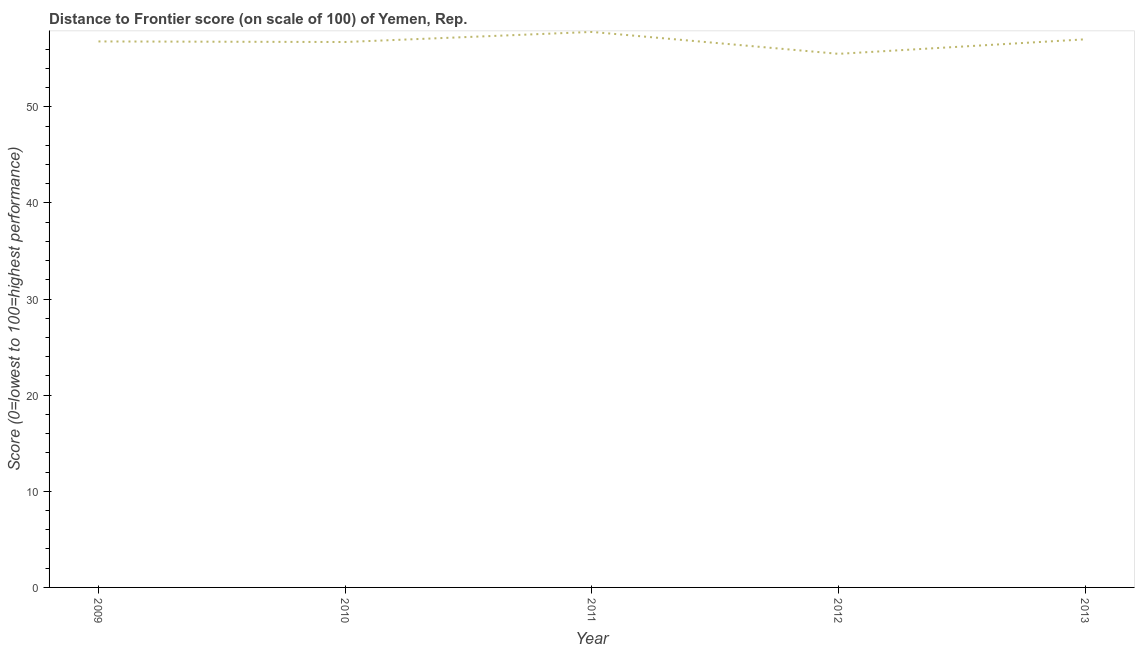What is the distance to frontier score in 2010?
Your response must be concise. 56.74. Across all years, what is the maximum distance to frontier score?
Keep it short and to the point. 57.79. Across all years, what is the minimum distance to frontier score?
Your answer should be compact. 55.51. In which year was the distance to frontier score minimum?
Offer a very short reply. 2012. What is the sum of the distance to frontier score?
Provide a succinct answer. 283.86. What is the difference between the distance to frontier score in 2010 and 2011?
Your answer should be compact. -1.05. What is the average distance to frontier score per year?
Your answer should be compact. 56.77. What is the median distance to frontier score?
Ensure brevity in your answer.  56.8. In how many years, is the distance to frontier score greater than 50 ?
Provide a short and direct response. 5. Do a majority of the years between 2009 and 2011 (inclusive) have distance to frontier score greater than 52 ?
Keep it short and to the point. Yes. What is the ratio of the distance to frontier score in 2010 to that in 2012?
Your response must be concise. 1.02. Is the distance to frontier score in 2009 less than that in 2013?
Give a very brief answer. Yes. Is the difference between the distance to frontier score in 2009 and 2010 greater than the difference between any two years?
Give a very brief answer. No. What is the difference between the highest and the second highest distance to frontier score?
Offer a terse response. 0.77. What is the difference between the highest and the lowest distance to frontier score?
Keep it short and to the point. 2.28. In how many years, is the distance to frontier score greater than the average distance to frontier score taken over all years?
Offer a very short reply. 3. Does the distance to frontier score monotonically increase over the years?
Offer a very short reply. No. How many lines are there?
Offer a very short reply. 1. What is the difference between two consecutive major ticks on the Y-axis?
Your answer should be compact. 10. Does the graph contain any zero values?
Your answer should be very brief. No. What is the title of the graph?
Provide a succinct answer. Distance to Frontier score (on scale of 100) of Yemen, Rep. What is the label or title of the Y-axis?
Your answer should be very brief. Score (0=lowest to 100=highest performance). What is the Score (0=lowest to 100=highest performance) in 2009?
Keep it short and to the point. 56.8. What is the Score (0=lowest to 100=highest performance) of 2010?
Offer a very short reply. 56.74. What is the Score (0=lowest to 100=highest performance) of 2011?
Provide a short and direct response. 57.79. What is the Score (0=lowest to 100=highest performance) of 2012?
Provide a succinct answer. 55.51. What is the Score (0=lowest to 100=highest performance) in 2013?
Make the answer very short. 57.02. What is the difference between the Score (0=lowest to 100=highest performance) in 2009 and 2010?
Provide a succinct answer. 0.06. What is the difference between the Score (0=lowest to 100=highest performance) in 2009 and 2011?
Make the answer very short. -0.99. What is the difference between the Score (0=lowest to 100=highest performance) in 2009 and 2012?
Provide a short and direct response. 1.29. What is the difference between the Score (0=lowest to 100=highest performance) in 2009 and 2013?
Make the answer very short. -0.22. What is the difference between the Score (0=lowest to 100=highest performance) in 2010 and 2011?
Make the answer very short. -1.05. What is the difference between the Score (0=lowest to 100=highest performance) in 2010 and 2012?
Ensure brevity in your answer.  1.23. What is the difference between the Score (0=lowest to 100=highest performance) in 2010 and 2013?
Ensure brevity in your answer.  -0.28. What is the difference between the Score (0=lowest to 100=highest performance) in 2011 and 2012?
Your answer should be compact. 2.28. What is the difference between the Score (0=lowest to 100=highest performance) in 2011 and 2013?
Make the answer very short. 0.77. What is the difference between the Score (0=lowest to 100=highest performance) in 2012 and 2013?
Provide a short and direct response. -1.51. What is the ratio of the Score (0=lowest to 100=highest performance) in 2009 to that in 2010?
Offer a terse response. 1. What is the ratio of the Score (0=lowest to 100=highest performance) in 2009 to that in 2012?
Your answer should be very brief. 1.02. What is the ratio of the Score (0=lowest to 100=highest performance) in 2010 to that in 2012?
Offer a terse response. 1.02. What is the ratio of the Score (0=lowest to 100=highest performance) in 2010 to that in 2013?
Offer a very short reply. 0.99. What is the ratio of the Score (0=lowest to 100=highest performance) in 2011 to that in 2012?
Your answer should be very brief. 1.04. What is the ratio of the Score (0=lowest to 100=highest performance) in 2012 to that in 2013?
Offer a terse response. 0.97. 